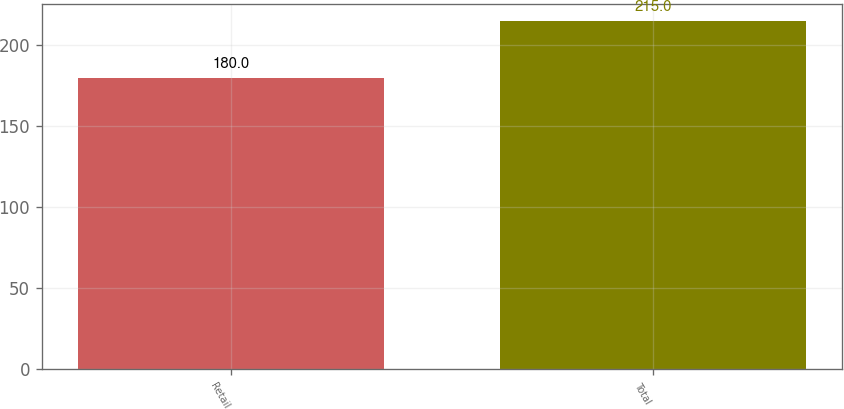Convert chart to OTSL. <chart><loc_0><loc_0><loc_500><loc_500><bar_chart><fcel>Retail<fcel>Total<nl><fcel>180<fcel>215<nl></chart> 